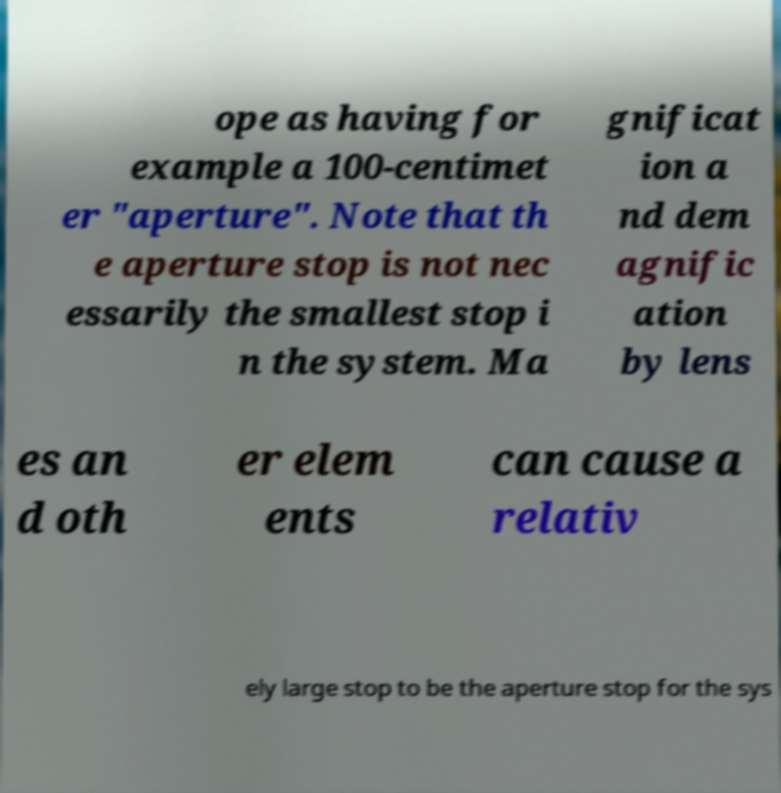Can you accurately transcribe the text from the provided image for me? ope as having for example a 100-centimet er "aperture". Note that th e aperture stop is not nec essarily the smallest stop i n the system. Ma gnificat ion a nd dem agnific ation by lens es an d oth er elem ents can cause a relativ ely large stop to be the aperture stop for the sys 